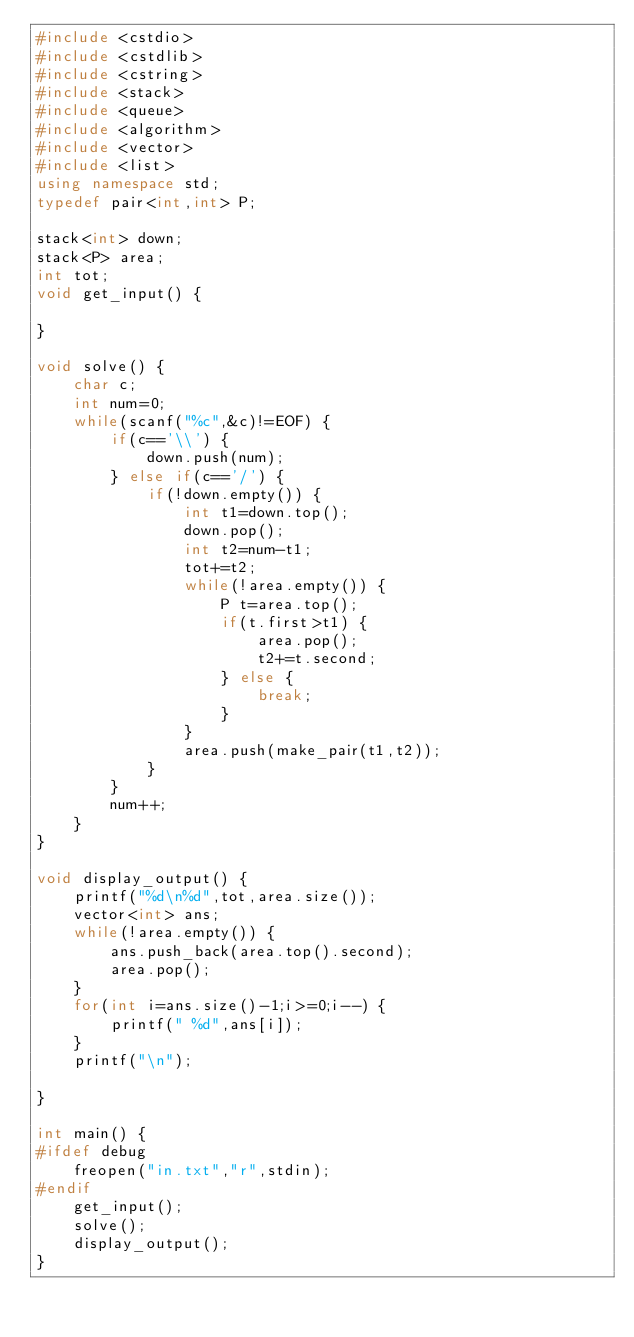<code> <loc_0><loc_0><loc_500><loc_500><_C++_>#include <cstdio>
#include <cstdlib>
#include <cstring>
#include <stack>
#include <queue>
#include <algorithm>
#include <vector>
#include <list>
using namespace std;
typedef pair<int,int> P;

stack<int> down;
stack<P> area;
int tot;
void get_input() {

}

void solve() {
    char c;
    int num=0;
    while(scanf("%c",&c)!=EOF) {
        if(c=='\\') {
            down.push(num);
        } else if(c=='/') {
            if(!down.empty()) {
                int t1=down.top();
                down.pop();
                int t2=num-t1;
                tot+=t2;
                while(!area.empty()) {
                    P t=area.top();
                    if(t.first>t1) {
                        area.pop();
                        t2+=t.second;
                    } else {
                        break;
                    }
                }
                area.push(make_pair(t1,t2));
            }
        }
        num++;
    }
}

void display_output() {
    printf("%d\n%d",tot,area.size());
    vector<int> ans;
    while(!area.empty()) {
        ans.push_back(area.top().second);
        area.pop();
    }
    for(int i=ans.size()-1;i>=0;i--) {
        printf(" %d",ans[i]);
    }
    printf("\n");

}

int main() {
#ifdef debug
    freopen("in.txt","r",stdin);
#endif
    get_input();
    solve();
    display_output();
}</code> 